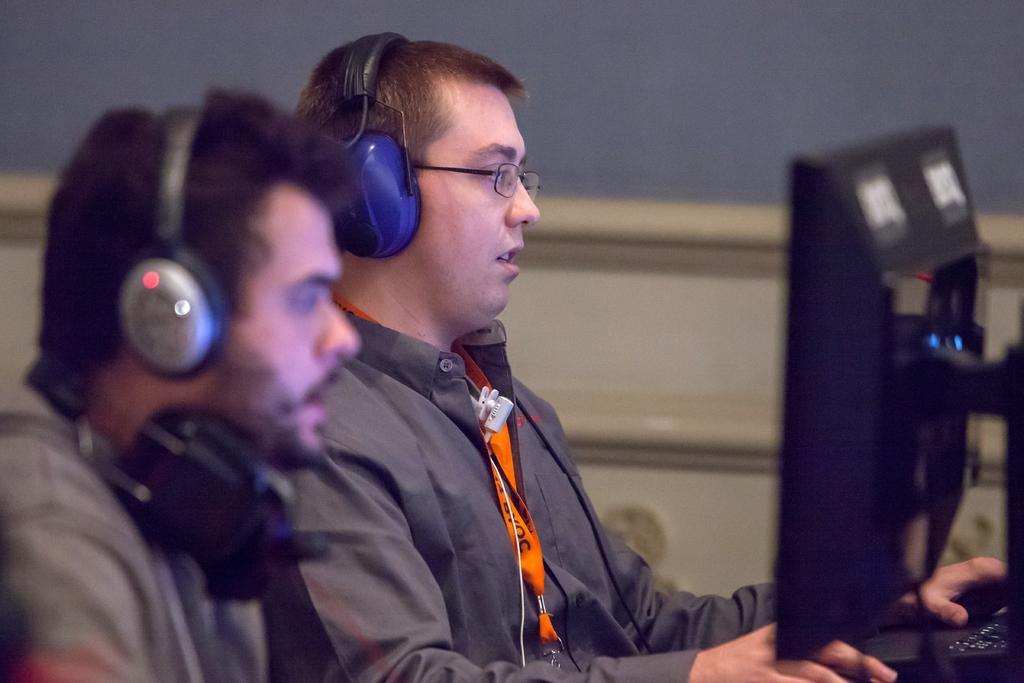How many people are in the image? There are two persons in the image. What are the two persons doing in the image? The two persons are sitting. What are the two persons wearing in the image? The two persons are wearing headphones. What can be seen on the right side of the image? There is a computer and a keyboard on the right side of the image. What type of pies are being baked in the apparatus in the image? There is no apparatus or pies present in the image. 